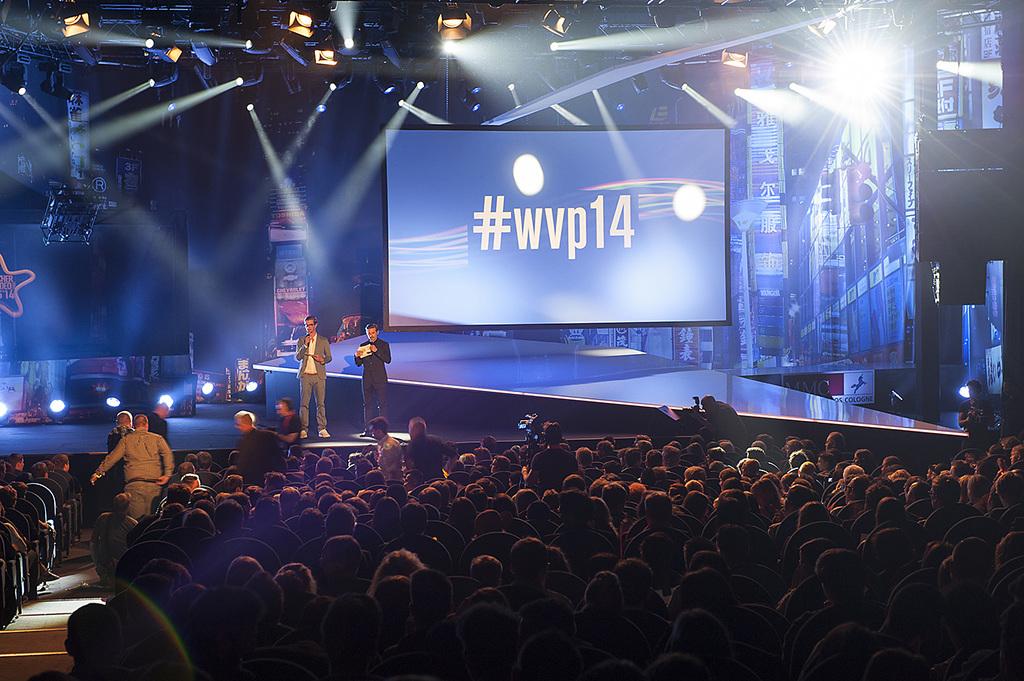What is the hashtag?
Give a very brief answer. #wvp14. 